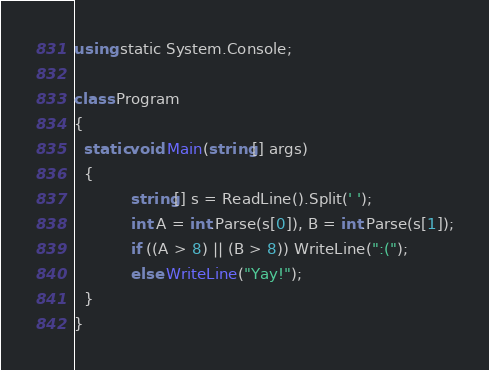<code> <loc_0><loc_0><loc_500><loc_500><_C#_>using static System.Console;

class Program
{
  static void Main(string[] args)
  {
			string[] s = ReadLine().Split(' ');
			int A = int.Parse(s[0]), B = int.Parse(s[1]);
			if ((A > 8) || (B > 8)) WriteLine(":(");
			else WriteLine("Yay!");
  }
}</code> 